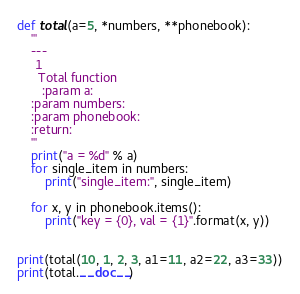Convert code to text. <code><loc_0><loc_0><loc_500><loc_500><_Python_>def total(a=5, *numbers, **phonebook):
    '''
    ---
     1
      Total function
       :param a:
    :param numbers:
    :param phonebook:
    :return:
    '''
    print("a = %d" % a)
    for single_item in numbers:
        print("single_item:", single_item)

    for x, y in phonebook.items():
        print("key = {0}, val = {1}".format(x, y))


print(total(10, 1, 2, 3, a1=11, a2=22, a3=33))
print(total.__doc__)
</code> 